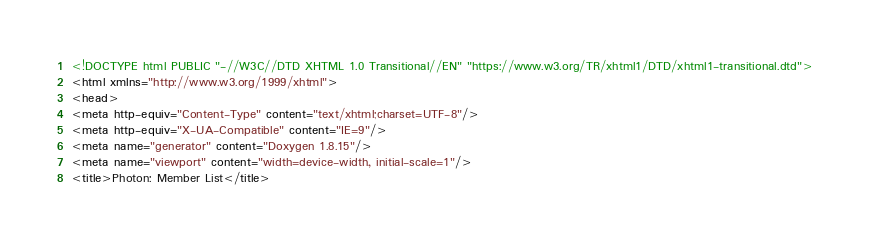<code> <loc_0><loc_0><loc_500><loc_500><_HTML_><!DOCTYPE html PUBLIC "-//W3C//DTD XHTML 1.0 Transitional//EN" "https://www.w3.org/TR/xhtml1/DTD/xhtml1-transitional.dtd">
<html xmlns="http://www.w3.org/1999/xhtml">
<head>
<meta http-equiv="Content-Type" content="text/xhtml;charset=UTF-8"/>
<meta http-equiv="X-UA-Compatible" content="IE=9"/>
<meta name="generator" content="Doxygen 1.8.15"/>
<meta name="viewport" content="width=device-width, initial-scale=1"/>
<title>Photon: Member List</title></code> 